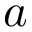Convert formula to latex. <formula><loc_0><loc_0><loc_500><loc_500>a</formula> 